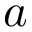Convert formula to latex. <formula><loc_0><loc_0><loc_500><loc_500>a</formula> 